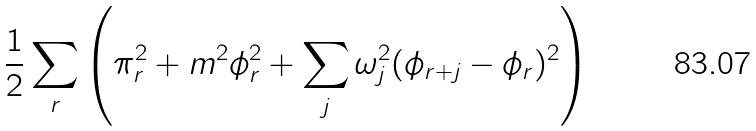<formula> <loc_0><loc_0><loc_500><loc_500>\frac { 1 } { 2 } \sum _ { r } \left ( \pi _ { r } ^ { 2 } + m ^ { 2 } \phi _ { r } ^ { 2 } + \sum _ { j } \omega _ { j } ^ { 2 } ( \phi _ { r + j } - \phi _ { r } ) ^ { 2 } \right )</formula> 